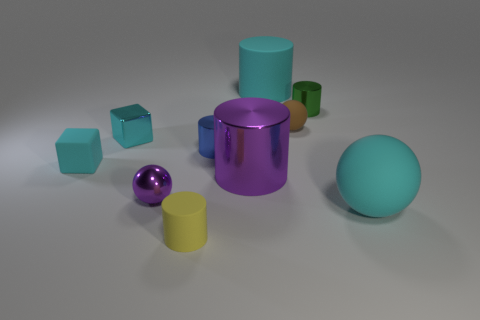Subtract all green cylinders. How many cylinders are left? 4 Subtract all yellow cylinders. How many cylinders are left? 4 Subtract all blue cylinders. Subtract all gray blocks. How many cylinders are left? 4 Subtract all balls. How many objects are left? 7 Add 3 tiny spheres. How many tiny spheres are left? 5 Add 1 red shiny cubes. How many red shiny cubes exist? 1 Subtract 1 cyan blocks. How many objects are left? 9 Subtract all brown matte balls. Subtract all red shiny cubes. How many objects are left? 9 